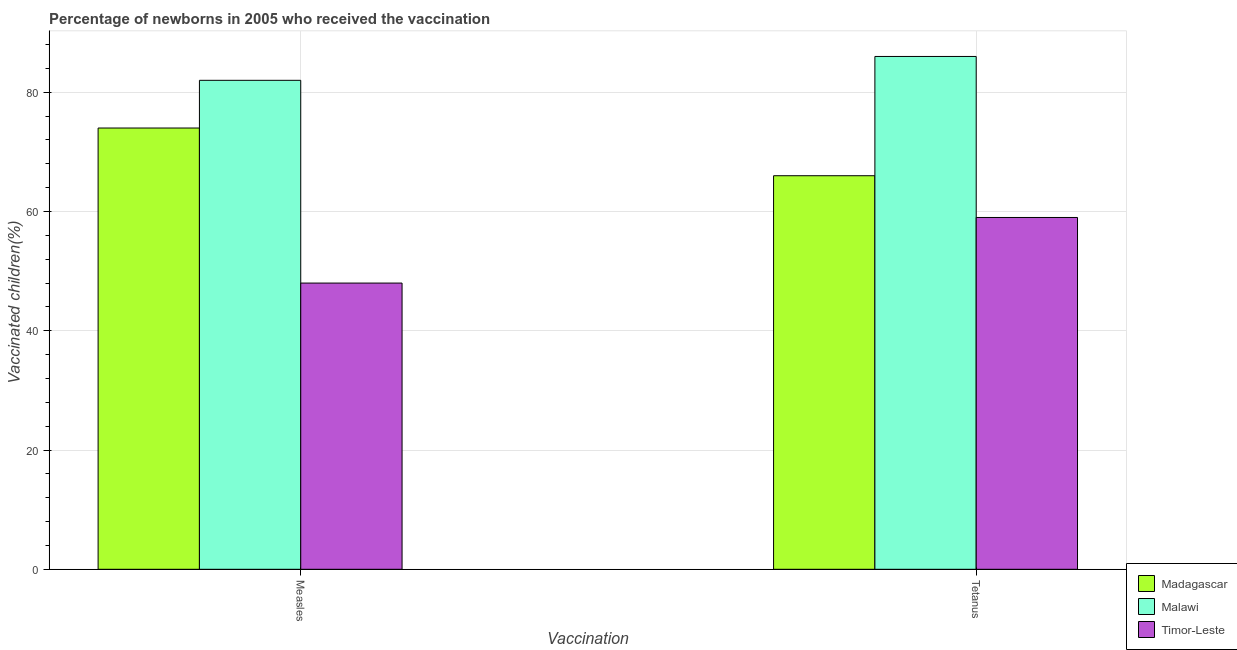How many different coloured bars are there?
Your answer should be compact. 3. Are the number of bars on each tick of the X-axis equal?
Offer a very short reply. Yes. How many bars are there on the 2nd tick from the left?
Ensure brevity in your answer.  3. How many bars are there on the 1st tick from the right?
Make the answer very short. 3. What is the label of the 2nd group of bars from the left?
Give a very brief answer. Tetanus. What is the percentage of newborns who received vaccination for tetanus in Timor-Leste?
Offer a very short reply. 59. Across all countries, what is the maximum percentage of newborns who received vaccination for measles?
Give a very brief answer. 82. Across all countries, what is the minimum percentage of newborns who received vaccination for tetanus?
Provide a short and direct response. 59. In which country was the percentage of newborns who received vaccination for measles maximum?
Ensure brevity in your answer.  Malawi. In which country was the percentage of newborns who received vaccination for tetanus minimum?
Provide a succinct answer. Timor-Leste. What is the total percentage of newborns who received vaccination for tetanus in the graph?
Your response must be concise. 211. What is the difference between the percentage of newborns who received vaccination for measles in Timor-Leste and that in Malawi?
Give a very brief answer. -34. What is the difference between the percentage of newborns who received vaccination for tetanus in Malawi and the percentage of newborns who received vaccination for measles in Madagascar?
Offer a terse response. 12. What is the average percentage of newborns who received vaccination for measles per country?
Your answer should be very brief. 68. What is the difference between the percentage of newborns who received vaccination for tetanus and percentage of newborns who received vaccination for measles in Timor-Leste?
Your response must be concise. 11. What is the ratio of the percentage of newborns who received vaccination for tetanus in Timor-Leste to that in Malawi?
Keep it short and to the point. 0.69. In how many countries, is the percentage of newborns who received vaccination for tetanus greater than the average percentage of newborns who received vaccination for tetanus taken over all countries?
Your response must be concise. 1. What does the 2nd bar from the left in Measles represents?
Your answer should be compact. Malawi. What does the 1st bar from the right in Measles represents?
Provide a short and direct response. Timor-Leste. How many bars are there?
Ensure brevity in your answer.  6. How many countries are there in the graph?
Offer a terse response. 3. What is the difference between two consecutive major ticks on the Y-axis?
Your answer should be compact. 20. Are the values on the major ticks of Y-axis written in scientific E-notation?
Provide a succinct answer. No. Does the graph contain any zero values?
Offer a terse response. No. Where does the legend appear in the graph?
Your response must be concise. Bottom right. How many legend labels are there?
Your answer should be very brief. 3. What is the title of the graph?
Your answer should be very brief. Percentage of newborns in 2005 who received the vaccination. What is the label or title of the X-axis?
Keep it short and to the point. Vaccination. What is the label or title of the Y-axis?
Ensure brevity in your answer.  Vaccinated children(%)
. What is the Vaccinated children(%)
 of Malawi in Measles?
Provide a succinct answer. 82. What is the Vaccinated children(%)
 of Malawi in Tetanus?
Keep it short and to the point. 86. What is the Vaccinated children(%)
 in Timor-Leste in Tetanus?
Offer a terse response. 59. Across all Vaccination, what is the maximum Vaccinated children(%)
 of Malawi?
Give a very brief answer. 86. Across all Vaccination, what is the minimum Vaccinated children(%)
 in Madagascar?
Offer a terse response. 66. What is the total Vaccinated children(%)
 in Madagascar in the graph?
Offer a terse response. 140. What is the total Vaccinated children(%)
 in Malawi in the graph?
Your answer should be very brief. 168. What is the total Vaccinated children(%)
 of Timor-Leste in the graph?
Keep it short and to the point. 107. What is the difference between the Vaccinated children(%)
 of Madagascar in Measles and that in Tetanus?
Your response must be concise. 8. What is the difference between the Vaccinated children(%)
 of Timor-Leste in Measles and that in Tetanus?
Your response must be concise. -11. What is the difference between the Vaccinated children(%)
 in Madagascar in Measles and the Vaccinated children(%)
 in Timor-Leste in Tetanus?
Provide a short and direct response. 15. What is the average Vaccinated children(%)
 of Madagascar per Vaccination?
Provide a succinct answer. 70. What is the average Vaccinated children(%)
 of Timor-Leste per Vaccination?
Your answer should be very brief. 53.5. What is the difference between the Vaccinated children(%)
 in Madagascar and Vaccinated children(%)
 in Timor-Leste in Measles?
Your response must be concise. 26. What is the difference between the Vaccinated children(%)
 in Malawi and Vaccinated children(%)
 in Timor-Leste in Measles?
Offer a very short reply. 34. What is the difference between the Vaccinated children(%)
 in Madagascar and Vaccinated children(%)
 in Malawi in Tetanus?
Provide a succinct answer. -20. What is the ratio of the Vaccinated children(%)
 of Madagascar in Measles to that in Tetanus?
Make the answer very short. 1.12. What is the ratio of the Vaccinated children(%)
 in Malawi in Measles to that in Tetanus?
Provide a succinct answer. 0.95. What is the ratio of the Vaccinated children(%)
 of Timor-Leste in Measles to that in Tetanus?
Ensure brevity in your answer.  0.81. What is the difference between the highest and the second highest Vaccinated children(%)
 in Madagascar?
Provide a succinct answer. 8. What is the difference between the highest and the lowest Vaccinated children(%)
 of Malawi?
Make the answer very short. 4. What is the difference between the highest and the lowest Vaccinated children(%)
 in Timor-Leste?
Provide a succinct answer. 11. 